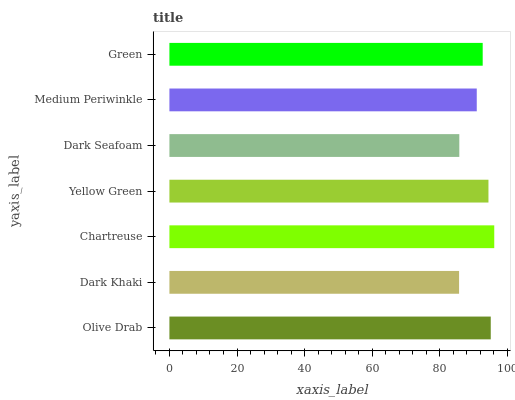Is Dark Khaki the minimum?
Answer yes or no. Yes. Is Chartreuse the maximum?
Answer yes or no. Yes. Is Chartreuse the minimum?
Answer yes or no. No. Is Dark Khaki the maximum?
Answer yes or no. No. Is Chartreuse greater than Dark Khaki?
Answer yes or no. Yes. Is Dark Khaki less than Chartreuse?
Answer yes or no. Yes. Is Dark Khaki greater than Chartreuse?
Answer yes or no. No. Is Chartreuse less than Dark Khaki?
Answer yes or no. No. Is Green the high median?
Answer yes or no. Yes. Is Green the low median?
Answer yes or no. Yes. Is Yellow Green the high median?
Answer yes or no. No. Is Yellow Green the low median?
Answer yes or no. No. 